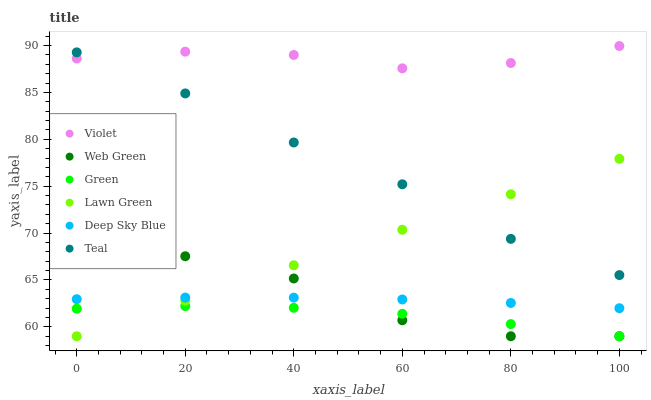Does Green have the minimum area under the curve?
Answer yes or no. Yes. Does Violet have the maximum area under the curve?
Answer yes or no. Yes. Does Deep Sky Blue have the minimum area under the curve?
Answer yes or no. No. Does Deep Sky Blue have the maximum area under the curve?
Answer yes or no. No. Is Lawn Green the smoothest?
Answer yes or no. Yes. Is Web Green the roughest?
Answer yes or no. Yes. Is Deep Sky Blue the smoothest?
Answer yes or no. No. Is Deep Sky Blue the roughest?
Answer yes or no. No. Does Lawn Green have the lowest value?
Answer yes or no. Yes. Does Deep Sky Blue have the lowest value?
Answer yes or no. No. Does Violet have the highest value?
Answer yes or no. Yes. Does Deep Sky Blue have the highest value?
Answer yes or no. No. Is Deep Sky Blue less than Violet?
Answer yes or no. Yes. Is Violet greater than Green?
Answer yes or no. Yes. Does Web Green intersect Lawn Green?
Answer yes or no. Yes. Is Web Green less than Lawn Green?
Answer yes or no. No. Is Web Green greater than Lawn Green?
Answer yes or no. No. Does Deep Sky Blue intersect Violet?
Answer yes or no. No. 